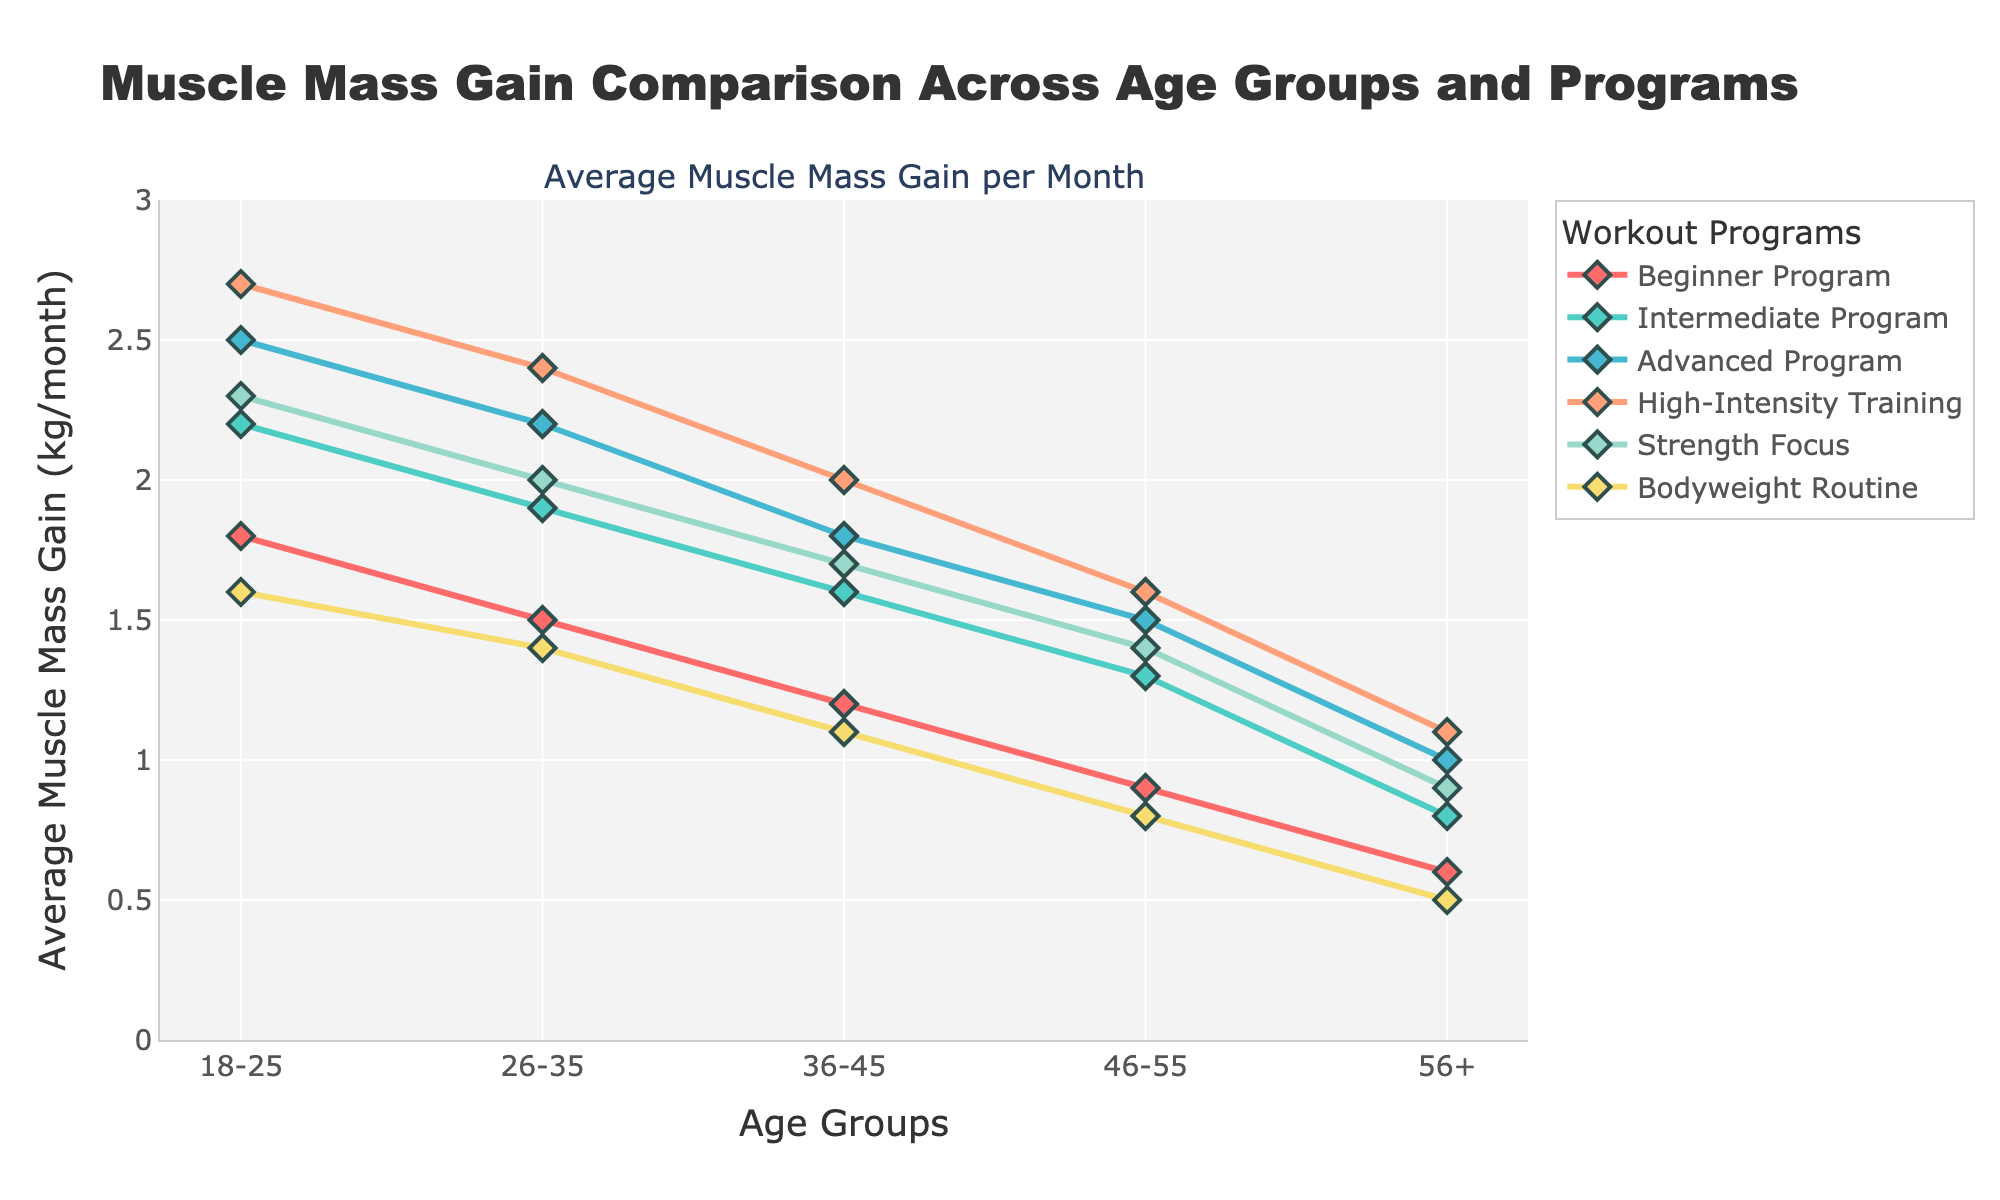which age group benefits the most from the Advanced Program compared to the Beginner Program? Compare the data points for the age groups in both the Advanced Program and the Beginner Program. The greatest difference in muscle mass gain between these two programs occurs in the 18-25 age group, where the gain is 2.5 kg/month for Advanced and 1.8 kg/month for Beginner, a difference of 0.7.
Answer: 18-25 among age groups 46-55, which program shows the highest average muscle mass gain per month? Review the muscle mass data for the 46-55 age group across all programs. The High-Intensity Training program displays the highest value at 1.6 kg/month.
Answer: High-Intensity Training how much more muscle mass does the Intermediate Program gain in the 26-35 age group compared to the 56+ age group? For the Intermediate Program, the gain for 26-35 is 1.9 kg/month and for 56+ it is 0.8 kg/month. Subtract the gain in the 56+ group from the 26-35 group (1.9 - 0.8) for a difference of 1.1 kg/month.
Answer: 1.1 which program shows the smallest variation in muscle mass gain across all age groups? Calculate the range for each program by subtracting the lowest gain from the highest gain within each program. The Bodyweight Routine has the smallest range, with a high of 1.6 and a low of 0.5 (1.6 - 0.5 = 1.1).
Answer: Bodyweight Routine overall, which age group shows the highest average muscle mass gain across all programs? Calculate the average gain for each age group by summing the muscle mass gains from all programs and dividing by the number of programs. The 18-25 group consistently has the highest values across all programs, suggesting they benefit the most.
Answer: 18-25 